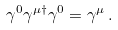<formula> <loc_0><loc_0><loc_500><loc_500>\gamma ^ { 0 } \gamma ^ { \mu \dagger } \gamma ^ { 0 } = \gamma ^ { \mu } \, .</formula> 